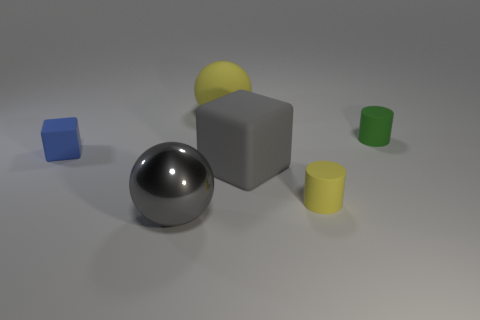Subtract all cubes. How many objects are left? 4 Add 4 large cyan shiny things. How many objects exist? 10 Subtract all cyan spheres. Subtract all green cubes. How many spheres are left? 2 Subtract all cyan spheres. How many blue blocks are left? 1 Subtract all big yellow metal cylinders. Subtract all large objects. How many objects are left? 3 Add 3 tiny blue matte cubes. How many tiny blue matte cubes are left? 4 Add 5 tiny red cylinders. How many tiny red cylinders exist? 5 Subtract 0 brown spheres. How many objects are left? 6 Subtract 2 balls. How many balls are left? 0 